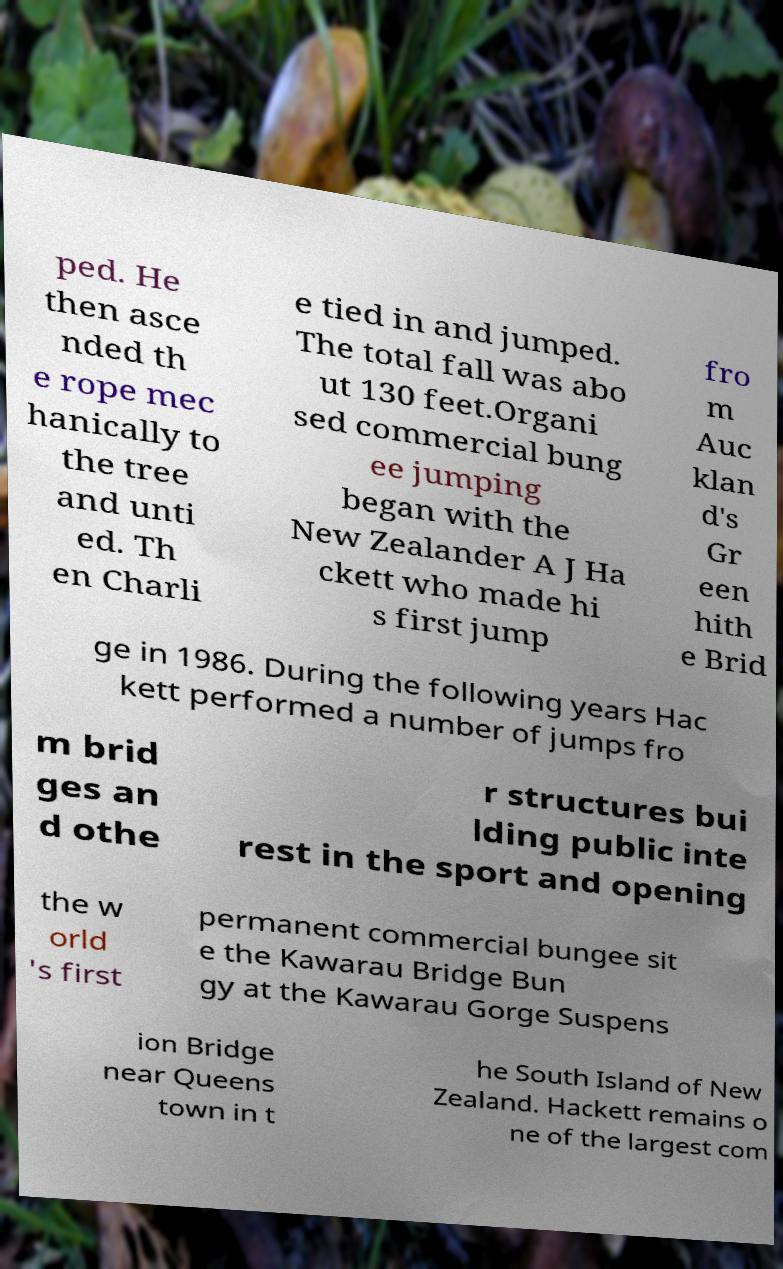What messages or text are displayed in this image? I need them in a readable, typed format. ped. He then asce nded th e rope mec hanically to the tree and unti ed. Th en Charli e tied in and jumped. The total fall was abo ut 130 feet.Organi sed commercial bung ee jumping began with the New Zealander A J Ha ckett who made hi s first jump fro m Auc klan d's Gr een hith e Brid ge in 1986. During the following years Hac kett performed a number of jumps fro m brid ges an d othe r structures bui lding public inte rest in the sport and opening the w orld 's first permanent commercial bungee sit e the Kawarau Bridge Bun gy at the Kawarau Gorge Suspens ion Bridge near Queens town in t he South Island of New Zealand. Hackett remains o ne of the largest com 